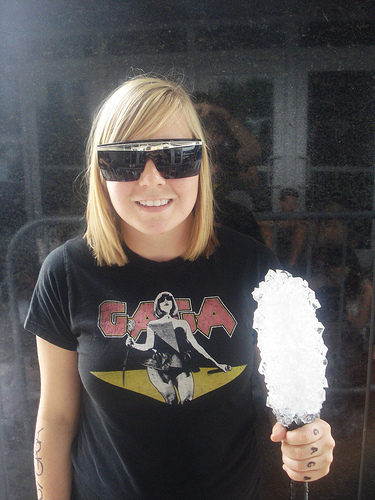<image>
Can you confirm if the ice cream is behind the woman? No. The ice cream is not behind the woman. From this viewpoint, the ice cream appears to be positioned elsewhere in the scene. 